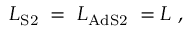Convert formula to latex. <formula><loc_0><loc_0><loc_500><loc_500>{ L } _ { S 2 } \, = \, { L } _ { A d S 2 } \, = L \ ,</formula> 